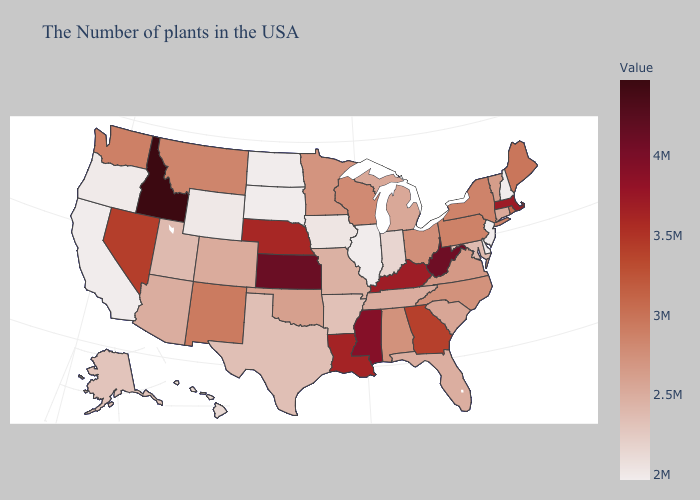Which states have the lowest value in the MidWest?
Concise answer only. Illinois, South Dakota, North Dakota. Does Illinois have a higher value than Virginia?
Keep it brief. No. Does the map have missing data?
Write a very short answer. No. Which states have the highest value in the USA?
Be succinct. Idaho. Among the states that border New Mexico , does Arizona have the lowest value?
Quick response, please. No. Does Kansas have a higher value than Oregon?
Quick response, please. Yes. Which states have the lowest value in the USA?
Concise answer only. New Hampshire, New Jersey, Delaware, Illinois, South Dakota, North Dakota, California. 